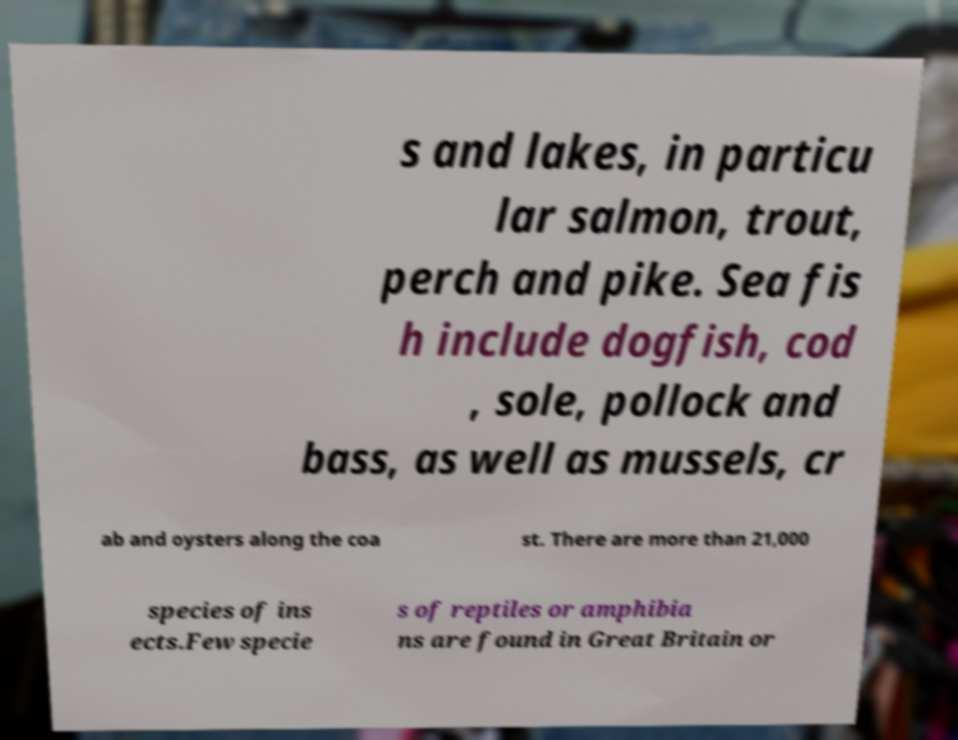For documentation purposes, I need the text within this image transcribed. Could you provide that? s and lakes, in particu lar salmon, trout, perch and pike. Sea fis h include dogfish, cod , sole, pollock and bass, as well as mussels, cr ab and oysters along the coa st. There are more than 21,000 species of ins ects.Few specie s of reptiles or amphibia ns are found in Great Britain or 